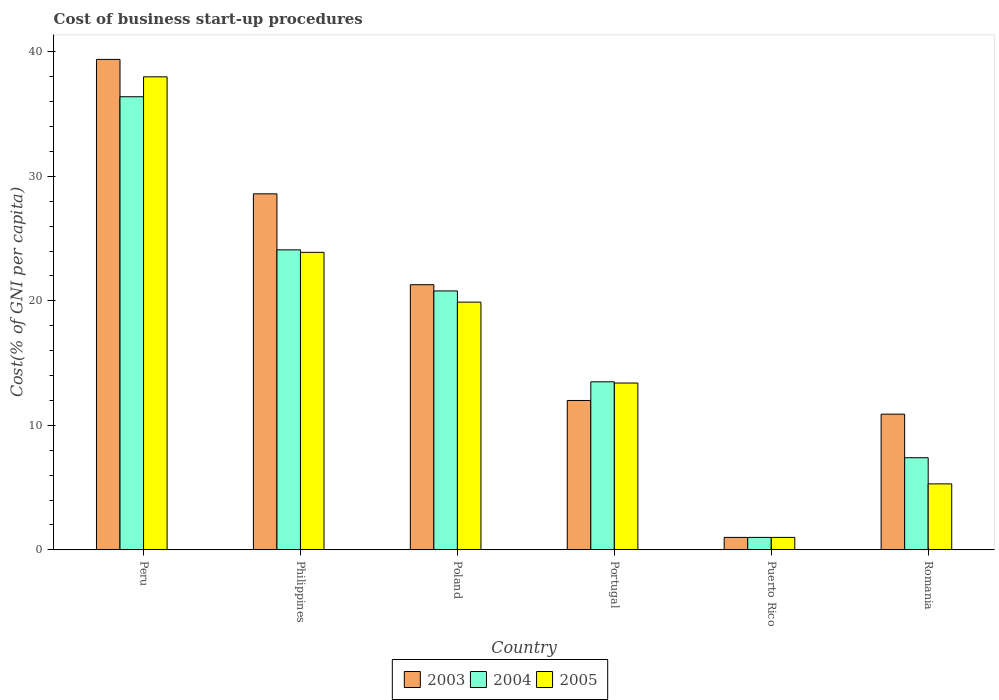How many different coloured bars are there?
Your response must be concise. 3. How many groups of bars are there?
Your answer should be very brief. 6. Are the number of bars per tick equal to the number of legend labels?
Ensure brevity in your answer.  Yes. Are the number of bars on each tick of the X-axis equal?
Give a very brief answer. Yes. How many bars are there on the 5th tick from the right?
Offer a terse response. 3. What is the label of the 2nd group of bars from the left?
Keep it short and to the point. Philippines. Across all countries, what is the maximum cost of business start-up procedures in 2004?
Your answer should be compact. 36.4. Across all countries, what is the minimum cost of business start-up procedures in 2005?
Keep it short and to the point. 1. In which country was the cost of business start-up procedures in 2005 maximum?
Provide a short and direct response. Peru. In which country was the cost of business start-up procedures in 2003 minimum?
Offer a terse response. Puerto Rico. What is the total cost of business start-up procedures in 2004 in the graph?
Your answer should be very brief. 103.2. What is the difference between the cost of business start-up procedures in 2003 in Poland and that in Portugal?
Make the answer very short. 9.3. What is the difference between the cost of business start-up procedures in 2004 in Poland and the cost of business start-up procedures in 2003 in Peru?
Keep it short and to the point. -18.6. What is the average cost of business start-up procedures in 2005 per country?
Your answer should be compact. 16.92. In how many countries, is the cost of business start-up procedures in 2005 greater than 16 %?
Provide a succinct answer. 3. What is the ratio of the cost of business start-up procedures in 2003 in Philippines to that in Puerto Rico?
Your answer should be very brief. 28.6. Is the difference between the cost of business start-up procedures in 2003 in Portugal and Puerto Rico greater than the difference between the cost of business start-up procedures in 2004 in Portugal and Puerto Rico?
Your response must be concise. No. What is the difference between the highest and the second highest cost of business start-up procedures in 2005?
Your answer should be very brief. -18.1. In how many countries, is the cost of business start-up procedures in 2003 greater than the average cost of business start-up procedures in 2003 taken over all countries?
Ensure brevity in your answer.  3. What does the 1st bar from the left in Puerto Rico represents?
Offer a very short reply. 2003. What does the 1st bar from the right in Poland represents?
Keep it short and to the point. 2005. Is it the case that in every country, the sum of the cost of business start-up procedures in 2003 and cost of business start-up procedures in 2005 is greater than the cost of business start-up procedures in 2004?
Offer a terse response. Yes. How many bars are there?
Offer a very short reply. 18. How many countries are there in the graph?
Provide a succinct answer. 6. What is the difference between two consecutive major ticks on the Y-axis?
Offer a very short reply. 10. Are the values on the major ticks of Y-axis written in scientific E-notation?
Your answer should be compact. No. Does the graph contain any zero values?
Give a very brief answer. No. Where does the legend appear in the graph?
Offer a very short reply. Bottom center. What is the title of the graph?
Offer a very short reply. Cost of business start-up procedures. Does "1964" appear as one of the legend labels in the graph?
Your response must be concise. No. What is the label or title of the X-axis?
Keep it short and to the point. Country. What is the label or title of the Y-axis?
Keep it short and to the point. Cost(% of GNI per capita). What is the Cost(% of GNI per capita) in 2003 in Peru?
Give a very brief answer. 39.4. What is the Cost(% of GNI per capita) in 2004 in Peru?
Provide a short and direct response. 36.4. What is the Cost(% of GNI per capita) of 2003 in Philippines?
Offer a very short reply. 28.6. What is the Cost(% of GNI per capita) of 2004 in Philippines?
Offer a terse response. 24.1. What is the Cost(% of GNI per capita) of 2005 in Philippines?
Provide a short and direct response. 23.9. What is the Cost(% of GNI per capita) of 2003 in Poland?
Ensure brevity in your answer.  21.3. What is the Cost(% of GNI per capita) of 2004 in Poland?
Ensure brevity in your answer.  20.8. What is the Cost(% of GNI per capita) in 2005 in Portugal?
Provide a succinct answer. 13.4. What is the Cost(% of GNI per capita) of 2003 in Puerto Rico?
Keep it short and to the point. 1. What is the Cost(% of GNI per capita) of 2004 in Puerto Rico?
Provide a short and direct response. 1. What is the Cost(% of GNI per capita) of 2003 in Romania?
Provide a short and direct response. 10.9. What is the Cost(% of GNI per capita) of 2004 in Romania?
Ensure brevity in your answer.  7.4. Across all countries, what is the maximum Cost(% of GNI per capita) of 2003?
Offer a very short reply. 39.4. Across all countries, what is the maximum Cost(% of GNI per capita) of 2004?
Provide a short and direct response. 36.4. What is the total Cost(% of GNI per capita) of 2003 in the graph?
Give a very brief answer. 113.2. What is the total Cost(% of GNI per capita) in 2004 in the graph?
Ensure brevity in your answer.  103.2. What is the total Cost(% of GNI per capita) in 2005 in the graph?
Keep it short and to the point. 101.5. What is the difference between the Cost(% of GNI per capita) of 2003 in Peru and that in Philippines?
Your answer should be compact. 10.8. What is the difference between the Cost(% of GNI per capita) in 2005 in Peru and that in Philippines?
Your answer should be compact. 14.1. What is the difference between the Cost(% of GNI per capita) of 2005 in Peru and that in Poland?
Keep it short and to the point. 18.1. What is the difference between the Cost(% of GNI per capita) in 2003 in Peru and that in Portugal?
Give a very brief answer. 27.4. What is the difference between the Cost(% of GNI per capita) of 2004 in Peru and that in Portugal?
Keep it short and to the point. 22.9. What is the difference between the Cost(% of GNI per capita) of 2005 in Peru and that in Portugal?
Your answer should be compact. 24.6. What is the difference between the Cost(% of GNI per capita) in 2003 in Peru and that in Puerto Rico?
Keep it short and to the point. 38.4. What is the difference between the Cost(% of GNI per capita) of 2004 in Peru and that in Puerto Rico?
Your answer should be very brief. 35.4. What is the difference between the Cost(% of GNI per capita) of 2003 in Peru and that in Romania?
Your answer should be very brief. 28.5. What is the difference between the Cost(% of GNI per capita) of 2004 in Peru and that in Romania?
Provide a short and direct response. 29. What is the difference between the Cost(% of GNI per capita) of 2005 in Peru and that in Romania?
Provide a succinct answer. 32.7. What is the difference between the Cost(% of GNI per capita) in 2003 in Philippines and that in Poland?
Offer a terse response. 7.3. What is the difference between the Cost(% of GNI per capita) of 2004 in Philippines and that in Poland?
Your answer should be compact. 3.3. What is the difference between the Cost(% of GNI per capita) in 2004 in Philippines and that in Portugal?
Make the answer very short. 10.6. What is the difference between the Cost(% of GNI per capita) of 2003 in Philippines and that in Puerto Rico?
Offer a terse response. 27.6. What is the difference between the Cost(% of GNI per capita) of 2004 in Philippines and that in Puerto Rico?
Your answer should be very brief. 23.1. What is the difference between the Cost(% of GNI per capita) in 2005 in Philippines and that in Puerto Rico?
Ensure brevity in your answer.  22.9. What is the difference between the Cost(% of GNI per capita) in 2003 in Poland and that in Portugal?
Keep it short and to the point. 9.3. What is the difference between the Cost(% of GNI per capita) of 2004 in Poland and that in Portugal?
Provide a short and direct response. 7.3. What is the difference between the Cost(% of GNI per capita) of 2003 in Poland and that in Puerto Rico?
Ensure brevity in your answer.  20.3. What is the difference between the Cost(% of GNI per capita) in 2004 in Poland and that in Puerto Rico?
Give a very brief answer. 19.8. What is the difference between the Cost(% of GNI per capita) in 2005 in Poland and that in Puerto Rico?
Your answer should be very brief. 18.9. What is the difference between the Cost(% of GNI per capita) in 2004 in Poland and that in Romania?
Give a very brief answer. 13.4. What is the difference between the Cost(% of GNI per capita) of 2005 in Poland and that in Romania?
Provide a short and direct response. 14.6. What is the difference between the Cost(% of GNI per capita) in 2003 in Portugal and that in Puerto Rico?
Offer a very short reply. 11. What is the difference between the Cost(% of GNI per capita) in 2003 in Portugal and that in Romania?
Your response must be concise. 1.1. What is the difference between the Cost(% of GNI per capita) in 2004 in Portugal and that in Romania?
Make the answer very short. 6.1. What is the difference between the Cost(% of GNI per capita) of 2005 in Portugal and that in Romania?
Your answer should be very brief. 8.1. What is the difference between the Cost(% of GNI per capita) of 2003 in Peru and the Cost(% of GNI per capita) of 2004 in Philippines?
Your response must be concise. 15.3. What is the difference between the Cost(% of GNI per capita) in 2004 in Peru and the Cost(% of GNI per capita) in 2005 in Philippines?
Make the answer very short. 12.5. What is the difference between the Cost(% of GNI per capita) in 2003 in Peru and the Cost(% of GNI per capita) in 2004 in Poland?
Ensure brevity in your answer.  18.6. What is the difference between the Cost(% of GNI per capita) of 2003 in Peru and the Cost(% of GNI per capita) of 2005 in Poland?
Provide a short and direct response. 19.5. What is the difference between the Cost(% of GNI per capita) of 2004 in Peru and the Cost(% of GNI per capita) of 2005 in Poland?
Your answer should be compact. 16.5. What is the difference between the Cost(% of GNI per capita) of 2003 in Peru and the Cost(% of GNI per capita) of 2004 in Portugal?
Offer a terse response. 25.9. What is the difference between the Cost(% of GNI per capita) of 2004 in Peru and the Cost(% of GNI per capita) of 2005 in Portugal?
Your answer should be very brief. 23. What is the difference between the Cost(% of GNI per capita) in 2003 in Peru and the Cost(% of GNI per capita) in 2004 in Puerto Rico?
Keep it short and to the point. 38.4. What is the difference between the Cost(% of GNI per capita) in 2003 in Peru and the Cost(% of GNI per capita) in 2005 in Puerto Rico?
Your answer should be very brief. 38.4. What is the difference between the Cost(% of GNI per capita) of 2004 in Peru and the Cost(% of GNI per capita) of 2005 in Puerto Rico?
Ensure brevity in your answer.  35.4. What is the difference between the Cost(% of GNI per capita) in 2003 in Peru and the Cost(% of GNI per capita) in 2005 in Romania?
Offer a terse response. 34.1. What is the difference between the Cost(% of GNI per capita) of 2004 in Peru and the Cost(% of GNI per capita) of 2005 in Romania?
Give a very brief answer. 31.1. What is the difference between the Cost(% of GNI per capita) of 2003 in Philippines and the Cost(% of GNI per capita) of 2004 in Poland?
Your answer should be very brief. 7.8. What is the difference between the Cost(% of GNI per capita) in 2003 in Philippines and the Cost(% of GNI per capita) in 2005 in Poland?
Provide a succinct answer. 8.7. What is the difference between the Cost(% of GNI per capita) in 2004 in Philippines and the Cost(% of GNI per capita) in 2005 in Poland?
Give a very brief answer. 4.2. What is the difference between the Cost(% of GNI per capita) in 2003 in Philippines and the Cost(% of GNI per capita) in 2005 in Portugal?
Offer a very short reply. 15.2. What is the difference between the Cost(% of GNI per capita) in 2004 in Philippines and the Cost(% of GNI per capita) in 2005 in Portugal?
Ensure brevity in your answer.  10.7. What is the difference between the Cost(% of GNI per capita) in 2003 in Philippines and the Cost(% of GNI per capita) in 2004 in Puerto Rico?
Keep it short and to the point. 27.6. What is the difference between the Cost(% of GNI per capita) of 2003 in Philippines and the Cost(% of GNI per capita) of 2005 in Puerto Rico?
Offer a terse response. 27.6. What is the difference between the Cost(% of GNI per capita) in 2004 in Philippines and the Cost(% of GNI per capita) in 2005 in Puerto Rico?
Provide a short and direct response. 23.1. What is the difference between the Cost(% of GNI per capita) in 2003 in Philippines and the Cost(% of GNI per capita) in 2004 in Romania?
Offer a very short reply. 21.2. What is the difference between the Cost(% of GNI per capita) in 2003 in Philippines and the Cost(% of GNI per capita) in 2005 in Romania?
Make the answer very short. 23.3. What is the difference between the Cost(% of GNI per capita) in 2004 in Philippines and the Cost(% of GNI per capita) in 2005 in Romania?
Give a very brief answer. 18.8. What is the difference between the Cost(% of GNI per capita) in 2003 in Poland and the Cost(% of GNI per capita) in 2005 in Portugal?
Your answer should be compact. 7.9. What is the difference between the Cost(% of GNI per capita) in 2003 in Poland and the Cost(% of GNI per capita) in 2004 in Puerto Rico?
Provide a succinct answer. 20.3. What is the difference between the Cost(% of GNI per capita) in 2003 in Poland and the Cost(% of GNI per capita) in 2005 in Puerto Rico?
Your answer should be very brief. 20.3. What is the difference between the Cost(% of GNI per capita) in 2004 in Poland and the Cost(% of GNI per capita) in 2005 in Puerto Rico?
Keep it short and to the point. 19.8. What is the difference between the Cost(% of GNI per capita) in 2003 in Poland and the Cost(% of GNI per capita) in 2004 in Romania?
Provide a succinct answer. 13.9. What is the difference between the Cost(% of GNI per capita) of 2003 in Portugal and the Cost(% of GNI per capita) of 2004 in Puerto Rico?
Give a very brief answer. 11. What is the difference between the Cost(% of GNI per capita) of 2004 in Portugal and the Cost(% of GNI per capita) of 2005 in Puerto Rico?
Offer a very short reply. 12.5. What is the difference between the Cost(% of GNI per capita) of 2003 in Portugal and the Cost(% of GNI per capita) of 2004 in Romania?
Your answer should be very brief. 4.6. What is the difference between the Cost(% of GNI per capita) of 2003 in Portugal and the Cost(% of GNI per capita) of 2005 in Romania?
Keep it short and to the point. 6.7. What is the difference between the Cost(% of GNI per capita) in 2004 in Portugal and the Cost(% of GNI per capita) in 2005 in Romania?
Provide a short and direct response. 8.2. What is the difference between the Cost(% of GNI per capita) of 2003 in Puerto Rico and the Cost(% of GNI per capita) of 2005 in Romania?
Ensure brevity in your answer.  -4.3. What is the average Cost(% of GNI per capita) of 2003 per country?
Your answer should be compact. 18.87. What is the average Cost(% of GNI per capita) in 2005 per country?
Your answer should be compact. 16.92. What is the difference between the Cost(% of GNI per capita) of 2003 and Cost(% of GNI per capita) of 2005 in Peru?
Give a very brief answer. 1.4. What is the difference between the Cost(% of GNI per capita) of 2003 and Cost(% of GNI per capita) of 2004 in Philippines?
Ensure brevity in your answer.  4.5. What is the difference between the Cost(% of GNI per capita) of 2003 and Cost(% of GNI per capita) of 2005 in Philippines?
Your answer should be very brief. 4.7. What is the difference between the Cost(% of GNI per capita) in 2003 and Cost(% of GNI per capita) in 2004 in Poland?
Keep it short and to the point. 0.5. What is the difference between the Cost(% of GNI per capita) in 2003 and Cost(% of GNI per capita) in 2004 in Puerto Rico?
Make the answer very short. 0. What is the difference between the Cost(% of GNI per capita) of 2003 and Cost(% of GNI per capita) of 2005 in Puerto Rico?
Provide a short and direct response. 0. What is the difference between the Cost(% of GNI per capita) in 2004 and Cost(% of GNI per capita) in 2005 in Romania?
Provide a short and direct response. 2.1. What is the ratio of the Cost(% of GNI per capita) in 2003 in Peru to that in Philippines?
Ensure brevity in your answer.  1.38. What is the ratio of the Cost(% of GNI per capita) in 2004 in Peru to that in Philippines?
Give a very brief answer. 1.51. What is the ratio of the Cost(% of GNI per capita) of 2005 in Peru to that in Philippines?
Your answer should be compact. 1.59. What is the ratio of the Cost(% of GNI per capita) of 2003 in Peru to that in Poland?
Provide a succinct answer. 1.85. What is the ratio of the Cost(% of GNI per capita) of 2004 in Peru to that in Poland?
Keep it short and to the point. 1.75. What is the ratio of the Cost(% of GNI per capita) in 2005 in Peru to that in Poland?
Your answer should be compact. 1.91. What is the ratio of the Cost(% of GNI per capita) of 2003 in Peru to that in Portugal?
Give a very brief answer. 3.28. What is the ratio of the Cost(% of GNI per capita) in 2004 in Peru to that in Portugal?
Your answer should be compact. 2.7. What is the ratio of the Cost(% of GNI per capita) in 2005 in Peru to that in Portugal?
Ensure brevity in your answer.  2.84. What is the ratio of the Cost(% of GNI per capita) in 2003 in Peru to that in Puerto Rico?
Your answer should be very brief. 39.4. What is the ratio of the Cost(% of GNI per capita) in 2004 in Peru to that in Puerto Rico?
Make the answer very short. 36.4. What is the ratio of the Cost(% of GNI per capita) in 2003 in Peru to that in Romania?
Offer a terse response. 3.61. What is the ratio of the Cost(% of GNI per capita) of 2004 in Peru to that in Romania?
Make the answer very short. 4.92. What is the ratio of the Cost(% of GNI per capita) in 2005 in Peru to that in Romania?
Make the answer very short. 7.17. What is the ratio of the Cost(% of GNI per capita) in 2003 in Philippines to that in Poland?
Offer a terse response. 1.34. What is the ratio of the Cost(% of GNI per capita) in 2004 in Philippines to that in Poland?
Your response must be concise. 1.16. What is the ratio of the Cost(% of GNI per capita) in 2005 in Philippines to that in Poland?
Offer a very short reply. 1.2. What is the ratio of the Cost(% of GNI per capita) in 2003 in Philippines to that in Portugal?
Your response must be concise. 2.38. What is the ratio of the Cost(% of GNI per capita) of 2004 in Philippines to that in Portugal?
Your response must be concise. 1.79. What is the ratio of the Cost(% of GNI per capita) in 2005 in Philippines to that in Portugal?
Provide a succinct answer. 1.78. What is the ratio of the Cost(% of GNI per capita) in 2003 in Philippines to that in Puerto Rico?
Provide a short and direct response. 28.6. What is the ratio of the Cost(% of GNI per capita) of 2004 in Philippines to that in Puerto Rico?
Provide a succinct answer. 24.1. What is the ratio of the Cost(% of GNI per capita) of 2005 in Philippines to that in Puerto Rico?
Offer a very short reply. 23.9. What is the ratio of the Cost(% of GNI per capita) of 2003 in Philippines to that in Romania?
Offer a very short reply. 2.62. What is the ratio of the Cost(% of GNI per capita) in 2004 in Philippines to that in Romania?
Offer a very short reply. 3.26. What is the ratio of the Cost(% of GNI per capita) in 2005 in Philippines to that in Romania?
Offer a very short reply. 4.51. What is the ratio of the Cost(% of GNI per capita) in 2003 in Poland to that in Portugal?
Your answer should be compact. 1.77. What is the ratio of the Cost(% of GNI per capita) in 2004 in Poland to that in Portugal?
Make the answer very short. 1.54. What is the ratio of the Cost(% of GNI per capita) of 2005 in Poland to that in Portugal?
Your response must be concise. 1.49. What is the ratio of the Cost(% of GNI per capita) of 2003 in Poland to that in Puerto Rico?
Make the answer very short. 21.3. What is the ratio of the Cost(% of GNI per capita) in 2004 in Poland to that in Puerto Rico?
Offer a very short reply. 20.8. What is the ratio of the Cost(% of GNI per capita) in 2005 in Poland to that in Puerto Rico?
Provide a short and direct response. 19.9. What is the ratio of the Cost(% of GNI per capita) of 2003 in Poland to that in Romania?
Offer a very short reply. 1.95. What is the ratio of the Cost(% of GNI per capita) in 2004 in Poland to that in Romania?
Offer a very short reply. 2.81. What is the ratio of the Cost(% of GNI per capita) in 2005 in Poland to that in Romania?
Provide a short and direct response. 3.75. What is the ratio of the Cost(% of GNI per capita) in 2003 in Portugal to that in Puerto Rico?
Your answer should be compact. 12. What is the ratio of the Cost(% of GNI per capita) of 2004 in Portugal to that in Puerto Rico?
Make the answer very short. 13.5. What is the ratio of the Cost(% of GNI per capita) of 2005 in Portugal to that in Puerto Rico?
Your response must be concise. 13.4. What is the ratio of the Cost(% of GNI per capita) of 2003 in Portugal to that in Romania?
Keep it short and to the point. 1.1. What is the ratio of the Cost(% of GNI per capita) in 2004 in Portugal to that in Romania?
Offer a terse response. 1.82. What is the ratio of the Cost(% of GNI per capita) of 2005 in Portugal to that in Romania?
Offer a terse response. 2.53. What is the ratio of the Cost(% of GNI per capita) in 2003 in Puerto Rico to that in Romania?
Keep it short and to the point. 0.09. What is the ratio of the Cost(% of GNI per capita) of 2004 in Puerto Rico to that in Romania?
Keep it short and to the point. 0.14. What is the ratio of the Cost(% of GNI per capita) in 2005 in Puerto Rico to that in Romania?
Your answer should be compact. 0.19. What is the difference between the highest and the second highest Cost(% of GNI per capita) of 2004?
Provide a short and direct response. 12.3. What is the difference between the highest and the lowest Cost(% of GNI per capita) of 2003?
Keep it short and to the point. 38.4. What is the difference between the highest and the lowest Cost(% of GNI per capita) in 2004?
Offer a terse response. 35.4. 